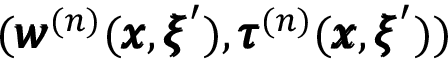<formula> <loc_0><loc_0><loc_500><loc_500>( { \pm b w } ^ { ( n ) } ( { \pm b x } , { \pm b \xi } ^ { \prime } ) , { \pm b \tau } ^ { ( n ) } ( { \pm b x } , { \pm b \xi } ^ { \prime } ) )</formula> 